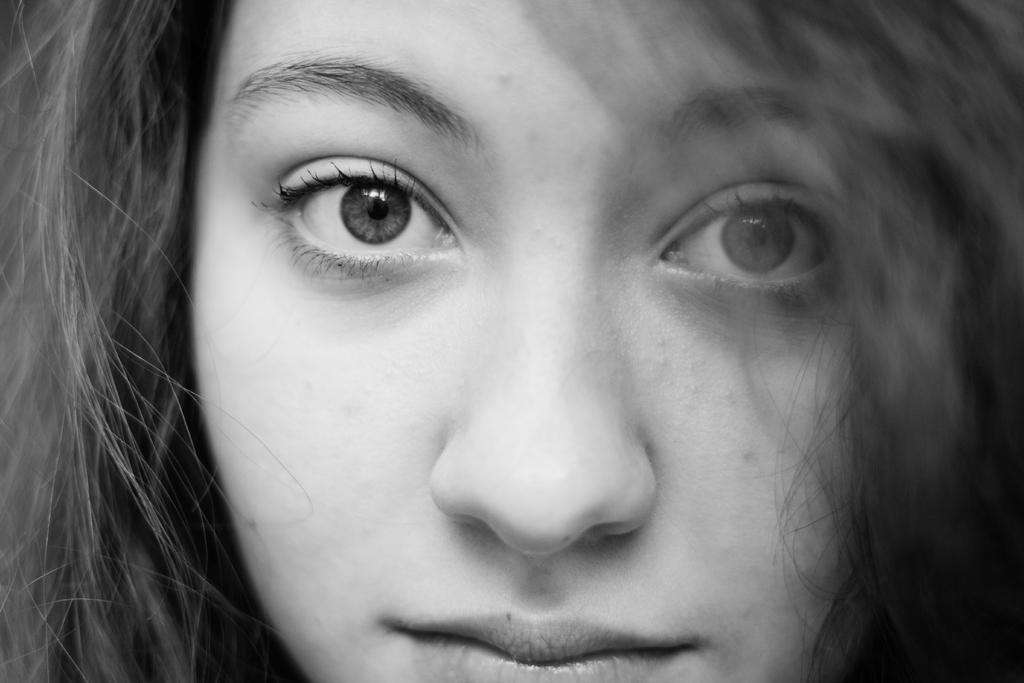Who is the main subject in the picture? There is a woman in the picture. What is the color of the woman's hair? The woman has black hair. How many eyes does the woman have? The woman has two eyes. How many nostrils does the woman have? The woman has one nose, which typically has two nostrils. How many openings does the woman have for speaking and eating? The woman has one mouth. What type of chickens can be seen fighting on the farm in the image? There is no farm, chickens, or fighting present in the image; it features a woman with black hair. 